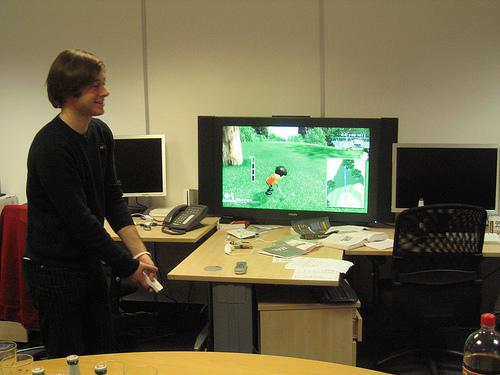Question: what game is on the tv?
Choices:
A. Soccer.
B. Tennis.
C. Golf.
D. Baseball.
Answer with the letter. Answer: C Question: where is this photo taken?
Choices:
A. Underwater.
B. At the beach.
C. In the bedroom.
D. An office.
Answer with the letter. Answer: D 